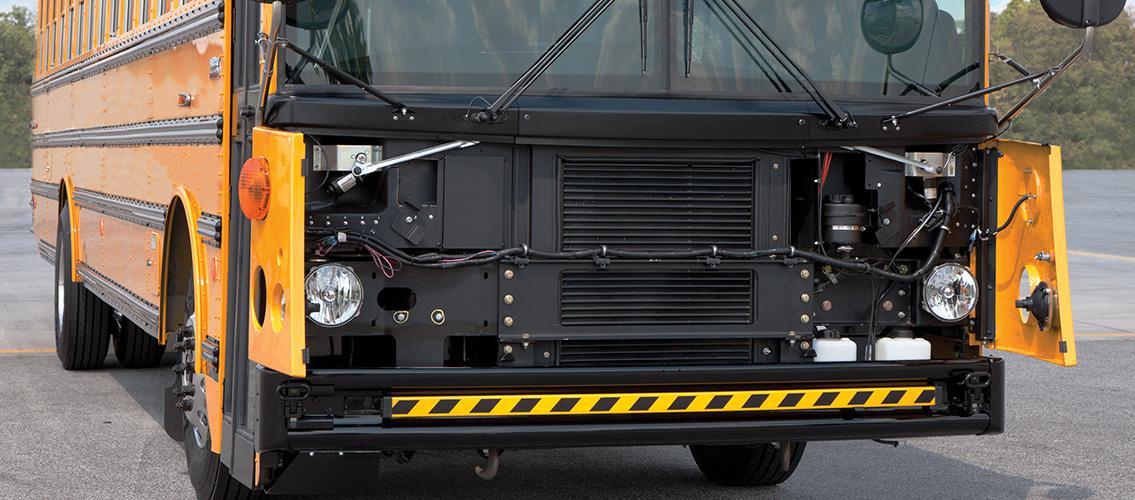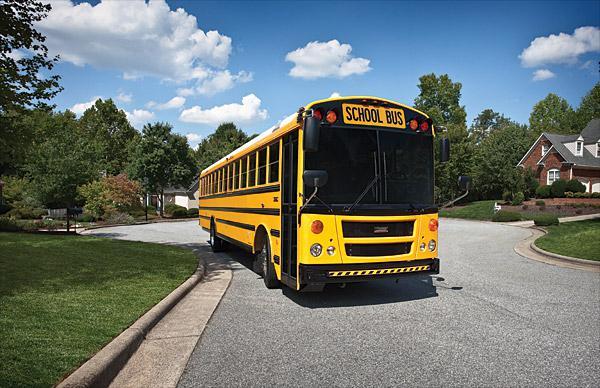The first image is the image on the left, the second image is the image on the right. For the images displayed, is the sentence "Each image shows a flat-fronted bus with a black-and-yellow striped line on its black bumper, and the buses on the left and right face the same direction." factually correct? Answer yes or no. Yes. The first image is the image on the left, the second image is the image on the right. Examine the images to the left and right. Is the description "In at least one image there is a single bus with a closed front grill facing slightly right" accurate? Answer yes or no. Yes. 